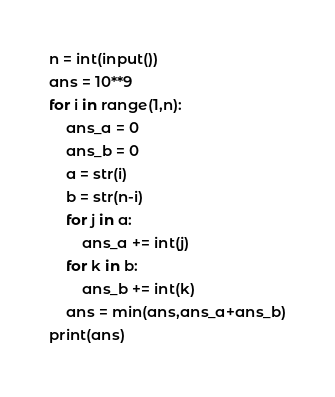<code> <loc_0><loc_0><loc_500><loc_500><_Python_>n = int(input())
ans = 10**9
for i in range(1,n):
    ans_a = 0
    ans_b = 0
    a = str(i)
    b = str(n-i)
    for j in a:
        ans_a += int(j)
    for k in b:
        ans_b += int(k)
    ans = min(ans,ans_a+ans_b)
print(ans)
</code> 